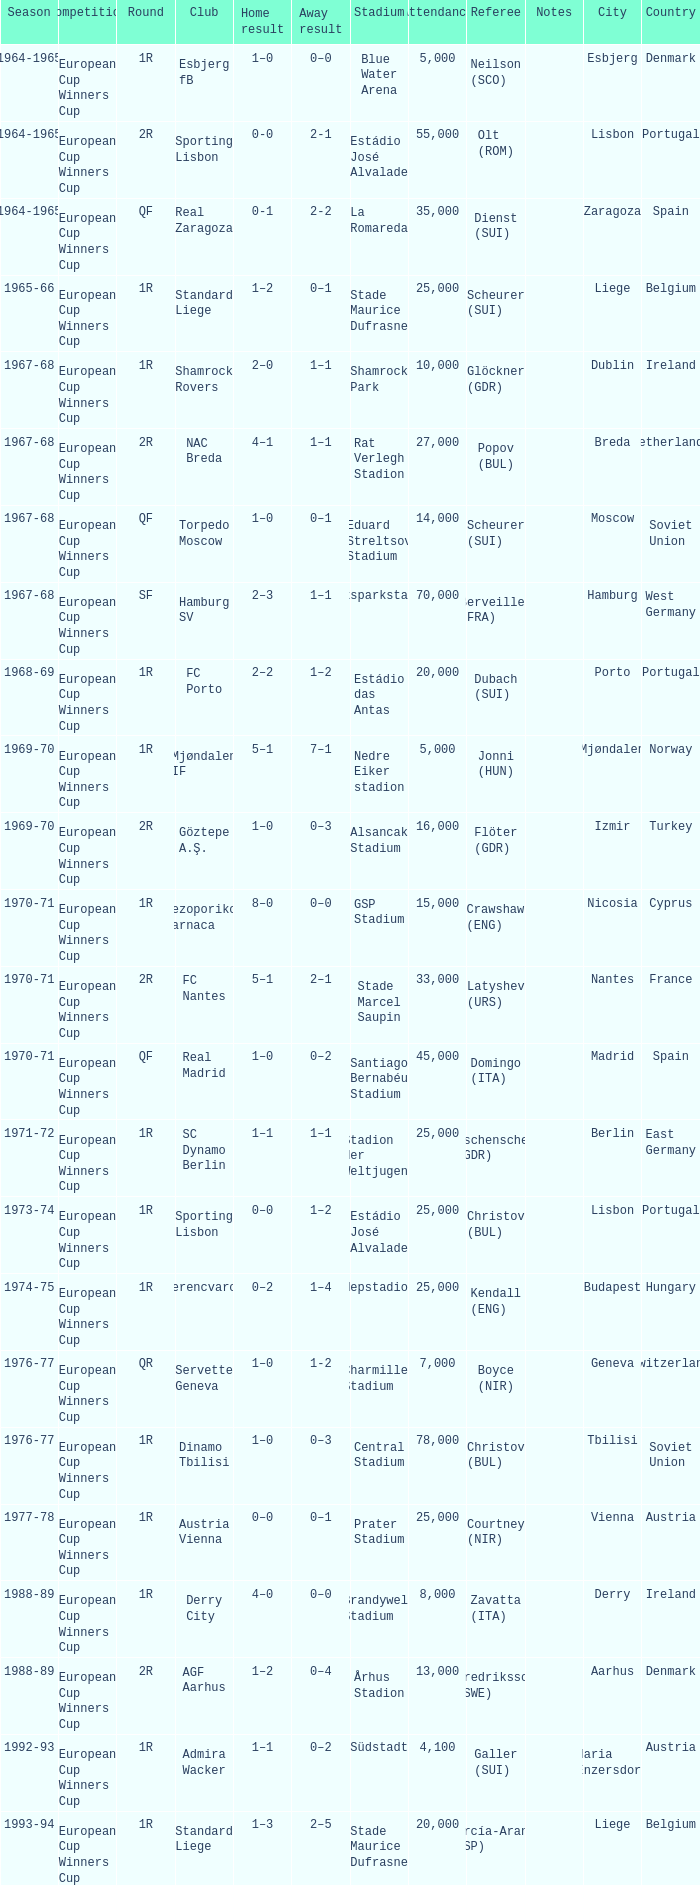Round of 1r, and an away result of 7–1 is what season? 1969-70. 